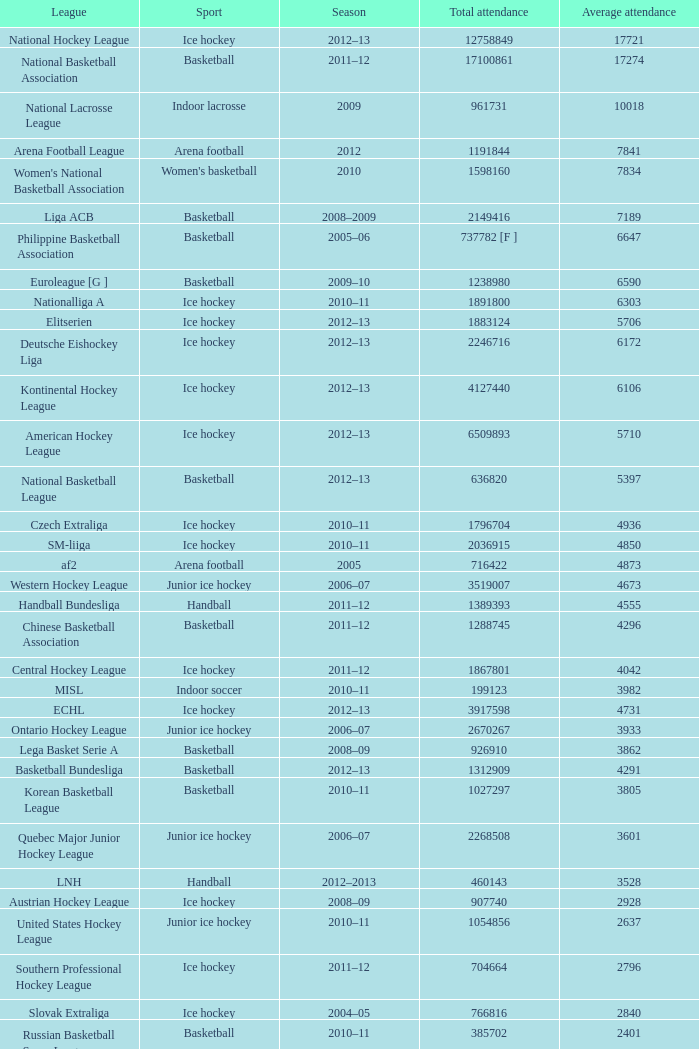What's the median attendance of the league with a total attendance of 2268508? 3601.0. 